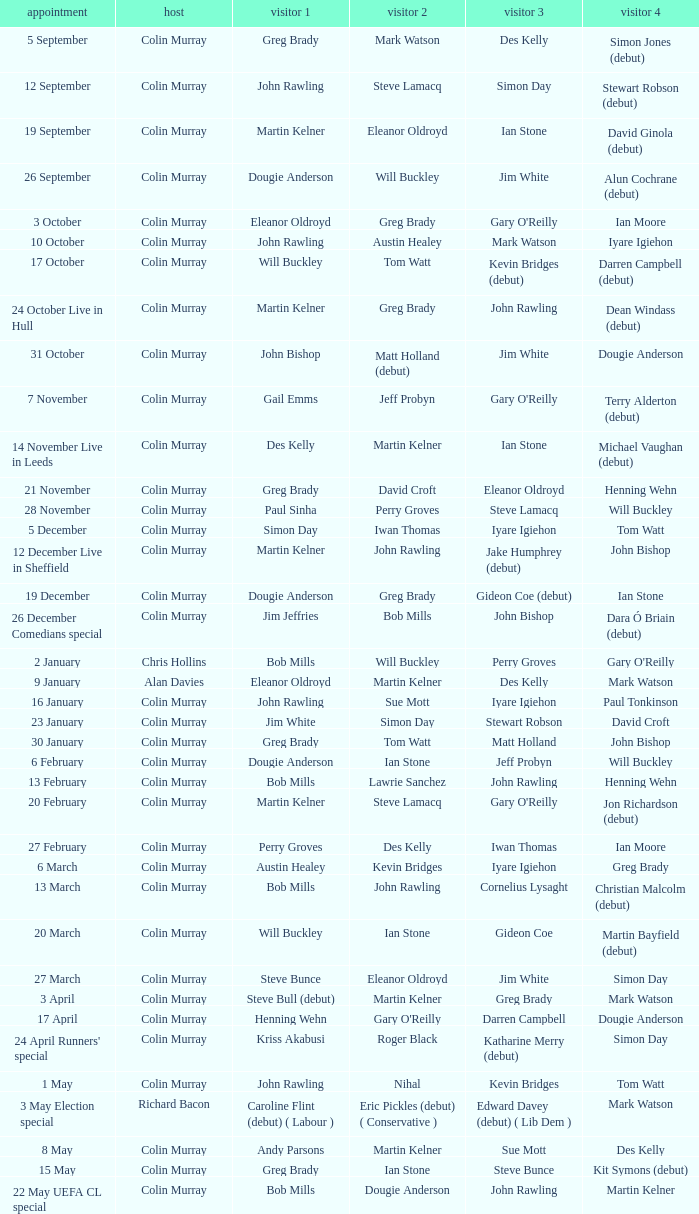On episodes where guest 1 is Jim White, who was guest 3? Stewart Robson. 